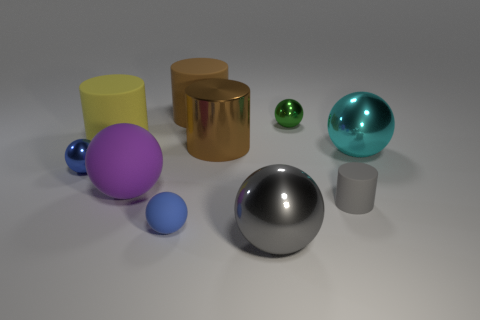There is a blue thing that is the same size as the blue metal sphere; what is its shape?
Offer a very short reply. Sphere. What number of large things are either brown cylinders or red rubber objects?
Offer a terse response. 2. There is a large cylinder behind the rubber thing that is on the left side of the purple thing; is there a yellow rubber cylinder behind it?
Provide a succinct answer. No. Are there any blue rubber things that have the same size as the cyan metal ball?
Your response must be concise. No. What is the material of the gray object that is the same size as the yellow rubber cylinder?
Provide a short and direct response. Metal. There is a cyan ball; does it have the same size as the sphere behind the cyan thing?
Your answer should be compact. No. What number of metallic objects are things or large brown objects?
Offer a very short reply. 5. What number of other metal things are the same shape as the big cyan metal object?
Give a very brief answer. 3. There is a object that is the same color as the metallic cylinder; what is it made of?
Offer a terse response. Rubber. Is the size of the brown cylinder that is right of the brown matte cylinder the same as the cylinder that is to the left of the brown matte thing?
Give a very brief answer. Yes. 